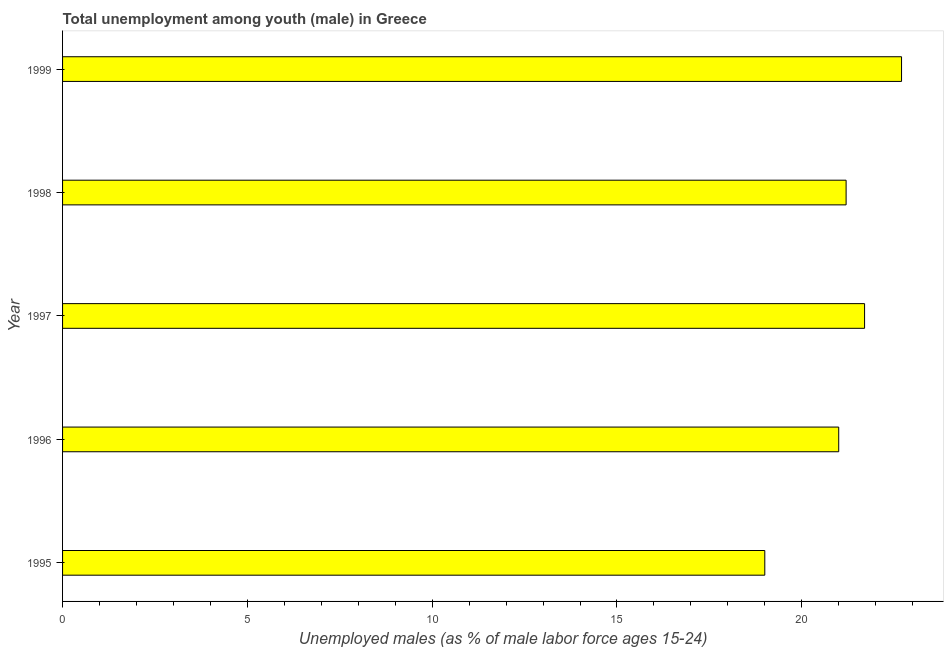Does the graph contain any zero values?
Offer a terse response. No. What is the title of the graph?
Ensure brevity in your answer.  Total unemployment among youth (male) in Greece. What is the label or title of the X-axis?
Your answer should be compact. Unemployed males (as % of male labor force ages 15-24). What is the unemployed male youth population in 1997?
Keep it short and to the point. 21.7. Across all years, what is the maximum unemployed male youth population?
Provide a succinct answer. 22.7. Across all years, what is the minimum unemployed male youth population?
Offer a terse response. 19. In which year was the unemployed male youth population maximum?
Make the answer very short. 1999. In which year was the unemployed male youth population minimum?
Provide a succinct answer. 1995. What is the sum of the unemployed male youth population?
Give a very brief answer. 105.6. What is the average unemployed male youth population per year?
Provide a short and direct response. 21.12. What is the median unemployed male youth population?
Your answer should be compact. 21.2. In how many years, is the unemployed male youth population greater than 9 %?
Make the answer very short. 5. What is the ratio of the unemployed male youth population in 1997 to that in 1998?
Keep it short and to the point. 1.02. Is the unemployed male youth population in 1995 less than that in 1999?
Offer a terse response. Yes. Is the sum of the unemployed male youth population in 1998 and 1999 greater than the maximum unemployed male youth population across all years?
Make the answer very short. Yes. What is the difference between the highest and the lowest unemployed male youth population?
Ensure brevity in your answer.  3.7. In how many years, is the unemployed male youth population greater than the average unemployed male youth population taken over all years?
Your response must be concise. 3. How many bars are there?
Offer a very short reply. 5. How many years are there in the graph?
Make the answer very short. 5. What is the Unemployed males (as % of male labor force ages 15-24) in 1995?
Your response must be concise. 19. What is the Unemployed males (as % of male labor force ages 15-24) of 1997?
Provide a succinct answer. 21.7. What is the Unemployed males (as % of male labor force ages 15-24) in 1998?
Your response must be concise. 21.2. What is the Unemployed males (as % of male labor force ages 15-24) in 1999?
Your answer should be compact. 22.7. What is the difference between the Unemployed males (as % of male labor force ages 15-24) in 1995 and 1996?
Your answer should be compact. -2. What is the difference between the Unemployed males (as % of male labor force ages 15-24) in 1995 and 1997?
Keep it short and to the point. -2.7. What is the difference between the Unemployed males (as % of male labor force ages 15-24) in 1995 and 1998?
Your answer should be compact. -2.2. What is the difference between the Unemployed males (as % of male labor force ages 15-24) in 1996 and 1998?
Provide a succinct answer. -0.2. What is the difference between the Unemployed males (as % of male labor force ages 15-24) in 1996 and 1999?
Offer a very short reply. -1.7. What is the difference between the Unemployed males (as % of male labor force ages 15-24) in 1997 and 1998?
Ensure brevity in your answer.  0.5. What is the ratio of the Unemployed males (as % of male labor force ages 15-24) in 1995 to that in 1996?
Offer a very short reply. 0.91. What is the ratio of the Unemployed males (as % of male labor force ages 15-24) in 1995 to that in 1997?
Make the answer very short. 0.88. What is the ratio of the Unemployed males (as % of male labor force ages 15-24) in 1995 to that in 1998?
Provide a succinct answer. 0.9. What is the ratio of the Unemployed males (as % of male labor force ages 15-24) in 1995 to that in 1999?
Offer a terse response. 0.84. What is the ratio of the Unemployed males (as % of male labor force ages 15-24) in 1996 to that in 1998?
Ensure brevity in your answer.  0.99. What is the ratio of the Unemployed males (as % of male labor force ages 15-24) in 1996 to that in 1999?
Ensure brevity in your answer.  0.93. What is the ratio of the Unemployed males (as % of male labor force ages 15-24) in 1997 to that in 1998?
Your response must be concise. 1.02. What is the ratio of the Unemployed males (as % of male labor force ages 15-24) in 1997 to that in 1999?
Offer a terse response. 0.96. What is the ratio of the Unemployed males (as % of male labor force ages 15-24) in 1998 to that in 1999?
Your answer should be compact. 0.93. 